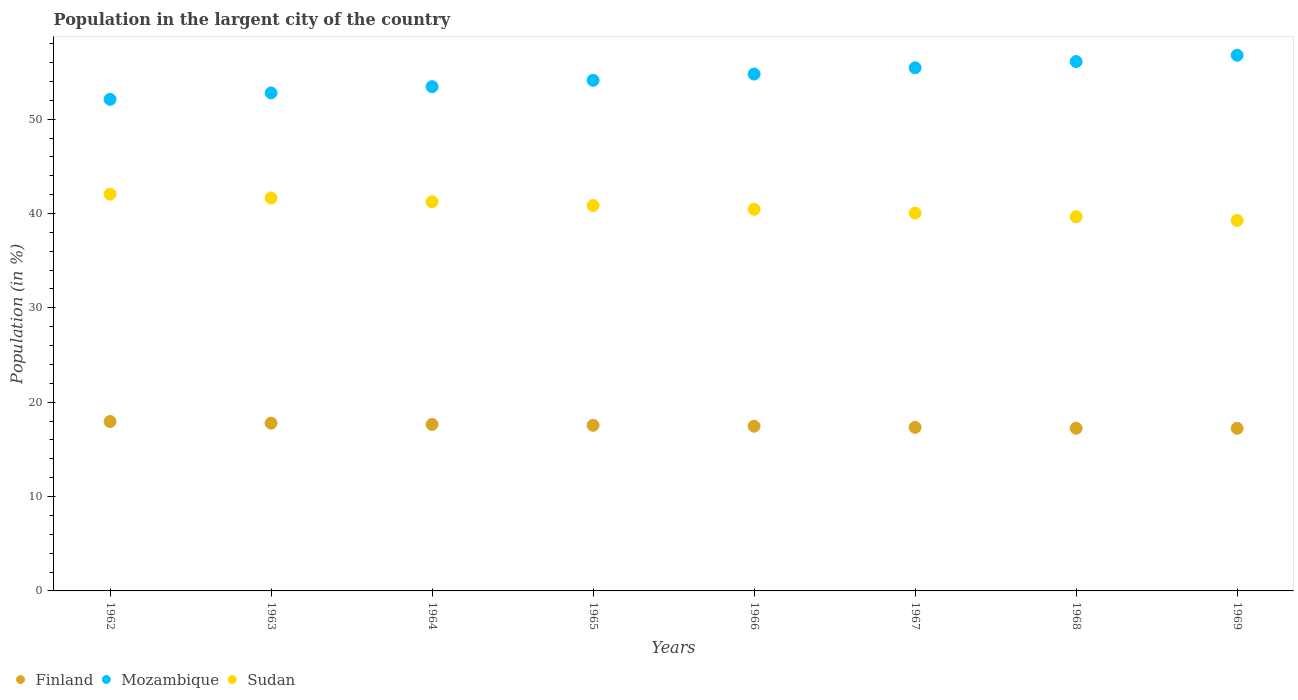Is the number of dotlines equal to the number of legend labels?
Make the answer very short. Yes. What is the percentage of population in the largent city in Mozambique in 1968?
Offer a very short reply. 56.11. Across all years, what is the maximum percentage of population in the largent city in Finland?
Offer a very short reply. 17.95. Across all years, what is the minimum percentage of population in the largent city in Sudan?
Ensure brevity in your answer.  39.27. In which year was the percentage of population in the largent city in Sudan maximum?
Ensure brevity in your answer.  1962. In which year was the percentage of population in the largent city in Finland minimum?
Provide a short and direct response. 1969. What is the total percentage of population in the largent city in Finland in the graph?
Offer a very short reply. 140.19. What is the difference between the percentage of population in the largent city in Sudan in 1962 and that in 1963?
Offer a very short reply. 0.4. What is the difference between the percentage of population in the largent city in Sudan in 1968 and the percentage of population in the largent city in Mozambique in 1965?
Your answer should be very brief. -14.46. What is the average percentage of population in the largent city in Mozambique per year?
Your answer should be compact. 54.44. In the year 1962, what is the difference between the percentage of population in the largent city in Finland and percentage of population in the largent city in Sudan?
Offer a terse response. -24.09. What is the ratio of the percentage of population in the largent city in Sudan in 1964 to that in 1966?
Your answer should be compact. 1.02. Is the difference between the percentage of population in the largent city in Finland in 1967 and 1969 greater than the difference between the percentage of population in the largent city in Sudan in 1967 and 1969?
Offer a very short reply. No. What is the difference between the highest and the second highest percentage of population in the largent city in Finland?
Provide a short and direct response. 0.17. What is the difference between the highest and the lowest percentage of population in the largent city in Sudan?
Your answer should be compact. 2.78. Is it the case that in every year, the sum of the percentage of population in the largent city in Finland and percentage of population in the largent city in Sudan  is greater than the percentage of population in the largent city in Mozambique?
Give a very brief answer. No. How many years are there in the graph?
Provide a short and direct response. 8. Where does the legend appear in the graph?
Your answer should be very brief. Bottom left. How many legend labels are there?
Give a very brief answer. 3. How are the legend labels stacked?
Keep it short and to the point. Horizontal. What is the title of the graph?
Your response must be concise. Population in the largent city of the country. Does "Paraguay" appear as one of the legend labels in the graph?
Your answer should be very brief. No. What is the label or title of the X-axis?
Your response must be concise. Years. What is the label or title of the Y-axis?
Your answer should be compact. Population (in %). What is the Population (in %) of Finland in 1962?
Your response must be concise. 17.95. What is the Population (in %) in Mozambique in 1962?
Offer a terse response. 52.1. What is the Population (in %) of Sudan in 1962?
Your response must be concise. 42.05. What is the Population (in %) of Finland in 1963?
Keep it short and to the point. 17.78. What is the Population (in %) of Mozambique in 1963?
Give a very brief answer. 52.78. What is the Population (in %) of Sudan in 1963?
Offer a terse response. 41.65. What is the Population (in %) of Finland in 1964?
Provide a short and direct response. 17.64. What is the Population (in %) of Mozambique in 1964?
Keep it short and to the point. 53.45. What is the Population (in %) of Sudan in 1964?
Offer a very short reply. 41.25. What is the Population (in %) of Finland in 1965?
Your answer should be very brief. 17.55. What is the Population (in %) in Mozambique in 1965?
Your answer should be compact. 54.12. What is the Population (in %) of Sudan in 1965?
Your response must be concise. 40.84. What is the Population (in %) in Finland in 1966?
Provide a succinct answer. 17.45. What is the Population (in %) in Mozambique in 1966?
Provide a short and direct response. 54.78. What is the Population (in %) of Sudan in 1966?
Your answer should be compact. 40.45. What is the Population (in %) of Finland in 1967?
Your response must be concise. 17.34. What is the Population (in %) in Mozambique in 1967?
Offer a very short reply. 55.44. What is the Population (in %) in Sudan in 1967?
Your answer should be very brief. 40.05. What is the Population (in %) in Finland in 1968?
Ensure brevity in your answer.  17.24. What is the Population (in %) in Mozambique in 1968?
Ensure brevity in your answer.  56.11. What is the Population (in %) of Sudan in 1968?
Ensure brevity in your answer.  39.66. What is the Population (in %) of Finland in 1969?
Provide a succinct answer. 17.23. What is the Population (in %) of Mozambique in 1969?
Provide a succinct answer. 56.78. What is the Population (in %) of Sudan in 1969?
Your response must be concise. 39.27. Across all years, what is the maximum Population (in %) in Finland?
Your answer should be very brief. 17.95. Across all years, what is the maximum Population (in %) of Mozambique?
Offer a very short reply. 56.78. Across all years, what is the maximum Population (in %) in Sudan?
Keep it short and to the point. 42.05. Across all years, what is the minimum Population (in %) in Finland?
Your answer should be very brief. 17.23. Across all years, what is the minimum Population (in %) of Mozambique?
Offer a very short reply. 52.1. Across all years, what is the minimum Population (in %) of Sudan?
Ensure brevity in your answer.  39.27. What is the total Population (in %) in Finland in the graph?
Your answer should be very brief. 140.19. What is the total Population (in %) in Mozambique in the graph?
Provide a short and direct response. 435.55. What is the total Population (in %) in Sudan in the graph?
Your response must be concise. 325.2. What is the difference between the Population (in %) of Finland in 1962 and that in 1963?
Make the answer very short. 0.17. What is the difference between the Population (in %) of Mozambique in 1962 and that in 1963?
Provide a short and direct response. -0.68. What is the difference between the Population (in %) of Sudan in 1962 and that in 1963?
Offer a terse response. 0.4. What is the difference between the Population (in %) in Finland in 1962 and that in 1964?
Give a very brief answer. 0.31. What is the difference between the Population (in %) in Mozambique in 1962 and that in 1964?
Your answer should be compact. -1.34. What is the difference between the Population (in %) in Sudan in 1962 and that in 1964?
Provide a succinct answer. 0.8. What is the difference between the Population (in %) in Finland in 1962 and that in 1965?
Offer a terse response. 0.4. What is the difference between the Population (in %) of Mozambique in 1962 and that in 1965?
Offer a very short reply. -2.02. What is the difference between the Population (in %) of Sudan in 1962 and that in 1965?
Make the answer very short. 1.2. What is the difference between the Population (in %) of Finland in 1962 and that in 1966?
Your response must be concise. 0.5. What is the difference between the Population (in %) in Mozambique in 1962 and that in 1966?
Provide a short and direct response. -2.68. What is the difference between the Population (in %) of Sudan in 1962 and that in 1966?
Your response must be concise. 1.6. What is the difference between the Population (in %) of Finland in 1962 and that in 1967?
Give a very brief answer. 0.62. What is the difference between the Population (in %) of Mozambique in 1962 and that in 1967?
Your response must be concise. -3.34. What is the difference between the Population (in %) of Sudan in 1962 and that in 1967?
Offer a terse response. 2. What is the difference between the Population (in %) of Finland in 1962 and that in 1968?
Make the answer very short. 0.72. What is the difference between the Population (in %) of Mozambique in 1962 and that in 1968?
Make the answer very short. -4. What is the difference between the Population (in %) in Sudan in 1962 and that in 1968?
Your answer should be very brief. 2.39. What is the difference between the Population (in %) in Finland in 1962 and that in 1969?
Ensure brevity in your answer.  0.72. What is the difference between the Population (in %) in Mozambique in 1962 and that in 1969?
Give a very brief answer. -4.67. What is the difference between the Population (in %) of Sudan in 1962 and that in 1969?
Offer a very short reply. 2.78. What is the difference between the Population (in %) of Finland in 1963 and that in 1964?
Offer a very short reply. 0.14. What is the difference between the Population (in %) of Mozambique in 1963 and that in 1964?
Ensure brevity in your answer.  -0.67. What is the difference between the Population (in %) in Sudan in 1963 and that in 1964?
Provide a succinct answer. 0.4. What is the difference between the Population (in %) in Finland in 1963 and that in 1965?
Your answer should be compact. 0.23. What is the difference between the Population (in %) in Mozambique in 1963 and that in 1965?
Your answer should be compact. -1.34. What is the difference between the Population (in %) of Sudan in 1963 and that in 1965?
Your answer should be compact. 0.8. What is the difference between the Population (in %) of Finland in 1963 and that in 1966?
Your answer should be very brief. 0.33. What is the difference between the Population (in %) in Mozambique in 1963 and that in 1966?
Offer a very short reply. -2. What is the difference between the Population (in %) of Sudan in 1963 and that in 1966?
Give a very brief answer. 1.2. What is the difference between the Population (in %) in Finland in 1963 and that in 1967?
Make the answer very short. 0.45. What is the difference between the Population (in %) of Mozambique in 1963 and that in 1967?
Your answer should be very brief. -2.66. What is the difference between the Population (in %) of Sudan in 1963 and that in 1967?
Provide a short and direct response. 1.6. What is the difference between the Population (in %) in Finland in 1963 and that in 1968?
Provide a succinct answer. 0.54. What is the difference between the Population (in %) of Mozambique in 1963 and that in 1968?
Your answer should be very brief. -3.32. What is the difference between the Population (in %) in Sudan in 1963 and that in 1968?
Provide a succinct answer. 1.99. What is the difference between the Population (in %) in Finland in 1963 and that in 1969?
Ensure brevity in your answer.  0.55. What is the difference between the Population (in %) in Mozambique in 1963 and that in 1969?
Provide a succinct answer. -4. What is the difference between the Population (in %) in Sudan in 1963 and that in 1969?
Provide a succinct answer. 2.38. What is the difference between the Population (in %) of Finland in 1964 and that in 1965?
Your response must be concise. 0.09. What is the difference between the Population (in %) in Mozambique in 1964 and that in 1965?
Give a very brief answer. -0.67. What is the difference between the Population (in %) of Sudan in 1964 and that in 1965?
Your answer should be compact. 0.4. What is the difference between the Population (in %) in Finland in 1964 and that in 1966?
Offer a very short reply. 0.19. What is the difference between the Population (in %) in Mozambique in 1964 and that in 1966?
Offer a very short reply. -1.33. What is the difference between the Population (in %) in Sudan in 1964 and that in 1966?
Your response must be concise. 0.8. What is the difference between the Population (in %) of Finland in 1964 and that in 1967?
Provide a short and direct response. 0.31. What is the difference between the Population (in %) in Mozambique in 1964 and that in 1967?
Provide a succinct answer. -2. What is the difference between the Population (in %) in Sudan in 1964 and that in 1967?
Your answer should be very brief. 1.2. What is the difference between the Population (in %) of Finland in 1964 and that in 1968?
Your response must be concise. 0.41. What is the difference between the Population (in %) in Mozambique in 1964 and that in 1968?
Make the answer very short. -2.66. What is the difference between the Population (in %) in Sudan in 1964 and that in 1968?
Keep it short and to the point. 1.59. What is the difference between the Population (in %) of Finland in 1964 and that in 1969?
Ensure brevity in your answer.  0.41. What is the difference between the Population (in %) in Mozambique in 1964 and that in 1969?
Give a very brief answer. -3.33. What is the difference between the Population (in %) in Sudan in 1964 and that in 1969?
Give a very brief answer. 1.98. What is the difference between the Population (in %) of Finland in 1965 and that in 1966?
Keep it short and to the point. 0.1. What is the difference between the Population (in %) of Mozambique in 1965 and that in 1966?
Give a very brief answer. -0.66. What is the difference between the Population (in %) in Sudan in 1965 and that in 1966?
Offer a very short reply. 0.4. What is the difference between the Population (in %) in Finland in 1965 and that in 1967?
Provide a succinct answer. 0.21. What is the difference between the Population (in %) in Mozambique in 1965 and that in 1967?
Make the answer very short. -1.32. What is the difference between the Population (in %) of Sudan in 1965 and that in 1967?
Provide a succinct answer. 0.8. What is the difference between the Population (in %) in Finland in 1965 and that in 1968?
Provide a short and direct response. 0.31. What is the difference between the Population (in %) in Mozambique in 1965 and that in 1968?
Your answer should be compact. -1.99. What is the difference between the Population (in %) in Sudan in 1965 and that in 1968?
Your response must be concise. 1.19. What is the difference between the Population (in %) of Finland in 1965 and that in 1969?
Offer a very short reply. 0.32. What is the difference between the Population (in %) in Mozambique in 1965 and that in 1969?
Provide a succinct answer. -2.66. What is the difference between the Population (in %) of Sudan in 1965 and that in 1969?
Provide a short and direct response. 1.58. What is the difference between the Population (in %) of Finland in 1966 and that in 1967?
Your answer should be compact. 0.12. What is the difference between the Population (in %) of Mozambique in 1966 and that in 1967?
Provide a short and direct response. -0.66. What is the difference between the Population (in %) of Sudan in 1966 and that in 1967?
Make the answer very short. 0.4. What is the difference between the Population (in %) in Finland in 1966 and that in 1968?
Give a very brief answer. 0.22. What is the difference between the Population (in %) of Mozambique in 1966 and that in 1968?
Provide a short and direct response. -1.32. What is the difference between the Population (in %) in Sudan in 1966 and that in 1968?
Provide a succinct answer. 0.79. What is the difference between the Population (in %) in Finland in 1966 and that in 1969?
Provide a succinct answer. 0.22. What is the difference between the Population (in %) in Mozambique in 1966 and that in 1969?
Give a very brief answer. -2. What is the difference between the Population (in %) of Sudan in 1966 and that in 1969?
Make the answer very short. 1.18. What is the difference between the Population (in %) in Finland in 1967 and that in 1968?
Give a very brief answer. 0.1. What is the difference between the Population (in %) of Mozambique in 1967 and that in 1968?
Make the answer very short. -0.66. What is the difference between the Population (in %) in Sudan in 1967 and that in 1968?
Your answer should be compact. 0.39. What is the difference between the Population (in %) in Finland in 1967 and that in 1969?
Make the answer very short. 0.1. What is the difference between the Population (in %) of Mozambique in 1967 and that in 1969?
Your answer should be compact. -1.33. What is the difference between the Population (in %) of Sudan in 1967 and that in 1969?
Keep it short and to the point. 0.78. What is the difference between the Population (in %) of Finland in 1968 and that in 1969?
Offer a very short reply. 0.01. What is the difference between the Population (in %) of Mozambique in 1968 and that in 1969?
Your answer should be compact. -0.67. What is the difference between the Population (in %) of Sudan in 1968 and that in 1969?
Give a very brief answer. 0.39. What is the difference between the Population (in %) in Finland in 1962 and the Population (in %) in Mozambique in 1963?
Give a very brief answer. -34.83. What is the difference between the Population (in %) in Finland in 1962 and the Population (in %) in Sudan in 1963?
Provide a short and direct response. -23.69. What is the difference between the Population (in %) of Mozambique in 1962 and the Population (in %) of Sudan in 1963?
Make the answer very short. 10.46. What is the difference between the Population (in %) in Finland in 1962 and the Population (in %) in Mozambique in 1964?
Your response must be concise. -35.49. What is the difference between the Population (in %) of Finland in 1962 and the Population (in %) of Sudan in 1964?
Provide a short and direct response. -23.29. What is the difference between the Population (in %) in Mozambique in 1962 and the Population (in %) in Sudan in 1964?
Give a very brief answer. 10.86. What is the difference between the Population (in %) in Finland in 1962 and the Population (in %) in Mozambique in 1965?
Offer a very short reply. -36.16. What is the difference between the Population (in %) of Finland in 1962 and the Population (in %) of Sudan in 1965?
Your response must be concise. -22.89. What is the difference between the Population (in %) in Mozambique in 1962 and the Population (in %) in Sudan in 1965?
Make the answer very short. 11.26. What is the difference between the Population (in %) in Finland in 1962 and the Population (in %) in Mozambique in 1966?
Offer a very short reply. -36.83. What is the difference between the Population (in %) in Finland in 1962 and the Population (in %) in Sudan in 1966?
Ensure brevity in your answer.  -22.49. What is the difference between the Population (in %) in Mozambique in 1962 and the Population (in %) in Sudan in 1966?
Provide a succinct answer. 11.66. What is the difference between the Population (in %) of Finland in 1962 and the Population (in %) of Mozambique in 1967?
Provide a short and direct response. -37.49. What is the difference between the Population (in %) in Finland in 1962 and the Population (in %) in Sudan in 1967?
Your answer should be compact. -22.09. What is the difference between the Population (in %) in Mozambique in 1962 and the Population (in %) in Sudan in 1967?
Offer a terse response. 12.05. What is the difference between the Population (in %) of Finland in 1962 and the Population (in %) of Mozambique in 1968?
Ensure brevity in your answer.  -38.15. What is the difference between the Population (in %) of Finland in 1962 and the Population (in %) of Sudan in 1968?
Your response must be concise. -21.7. What is the difference between the Population (in %) of Mozambique in 1962 and the Population (in %) of Sudan in 1968?
Provide a succinct answer. 12.45. What is the difference between the Population (in %) of Finland in 1962 and the Population (in %) of Mozambique in 1969?
Make the answer very short. -38.82. What is the difference between the Population (in %) in Finland in 1962 and the Population (in %) in Sudan in 1969?
Make the answer very short. -21.31. What is the difference between the Population (in %) in Mozambique in 1962 and the Population (in %) in Sudan in 1969?
Offer a terse response. 12.84. What is the difference between the Population (in %) in Finland in 1963 and the Population (in %) in Mozambique in 1964?
Offer a terse response. -35.66. What is the difference between the Population (in %) in Finland in 1963 and the Population (in %) in Sudan in 1964?
Your response must be concise. -23.46. What is the difference between the Population (in %) of Mozambique in 1963 and the Population (in %) of Sudan in 1964?
Ensure brevity in your answer.  11.53. What is the difference between the Population (in %) of Finland in 1963 and the Population (in %) of Mozambique in 1965?
Your response must be concise. -36.33. What is the difference between the Population (in %) of Finland in 1963 and the Population (in %) of Sudan in 1965?
Your response must be concise. -23.06. What is the difference between the Population (in %) in Mozambique in 1963 and the Population (in %) in Sudan in 1965?
Provide a short and direct response. 11.94. What is the difference between the Population (in %) in Finland in 1963 and the Population (in %) in Mozambique in 1966?
Your answer should be compact. -37. What is the difference between the Population (in %) in Finland in 1963 and the Population (in %) in Sudan in 1966?
Ensure brevity in your answer.  -22.66. What is the difference between the Population (in %) in Mozambique in 1963 and the Population (in %) in Sudan in 1966?
Make the answer very short. 12.33. What is the difference between the Population (in %) of Finland in 1963 and the Population (in %) of Mozambique in 1967?
Offer a very short reply. -37.66. What is the difference between the Population (in %) of Finland in 1963 and the Population (in %) of Sudan in 1967?
Your answer should be compact. -22.27. What is the difference between the Population (in %) of Mozambique in 1963 and the Population (in %) of Sudan in 1967?
Offer a terse response. 12.73. What is the difference between the Population (in %) in Finland in 1963 and the Population (in %) in Mozambique in 1968?
Keep it short and to the point. -38.32. What is the difference between the Population (in %) of Finland in 1963 and the Population (in %) of Sudan in 1968?
Give a very brief answer. -21.87. What is the difference between the Population (in %) of Mozambique in 1963 and the Population (in %) of Sudan in 1968?
Ensure brevity in your answer.  13.12. What is the difference between the Population (in %) in Finland in 1963 and the Population (in %) in Mozambique in 1969?
Provide a short and direct response. -38.99. What is the difference between the Population (in %) in Finland in 1963 and the Population (in %) in Sudan in 1969?
Provide a short and direct response. -21.48. What is the difference between the Population (in %) in Mozambique in 1963 and the Population (in %) in Sudan in 1969?
Your answer should be compact. 13.51. What is the difference between the Population (in %) of Finland in 1964 and the Population (in %) of Mozambique in 1965?
Provide a succinct answer. -36.47. What is the difference between the Population (in %) of Finland in 1964 and the Population (in %) of Sudan in 1965?
Offer a terse response. -23.2. What is the difference between the Population (in %) of Mozambique in 1964 and the Population (in %) of Sudan in 1965?
Your answer should be compact. 12.6. What is the difference between the Population (in %) in Finland in 1964 and the Population (in %) in Mozambique in 1966?
Provide a short and direct response. -37.14. What is the difference between the Population (in %) of Finland in 1964 and the Population (in %) of Sudan in 1966?
Provide a short and direct response. -22.8. What is the difference between the Population (in %) in Mozambique in 1964 and the Population (in %) in Sudan in 1966?
Provide a short and direct response. 13. What is the difference between the Population (in %) in Finland in 1964 and the Population (in %) in Mozambique in 1967?
Keep it short and to the point. -37.8. What is the difference between the Population (in %) of Finland in 1964 and the Population (in %) of Sudan in 1967?
Offer a terse response. -22.4. What is the difference between the Population (in %) of Mozambique in 1964 and the Population (in %) of Sudan in 1967?
Provide a succinct answer. 13.4. What is the difference between the Population (in %) in Finland in 1964 and the Population (in %) in Mozambique in 1968?
Your answer should be very brief. -38.46. What is the difference between the Population (in %) of Finland in 1964 and the Population (in %) of Sudan in 1968?
Provide a succinct answer. -22.01. What is the difference between the Population (in %) in Mozambique in 1964 and the Population (in %) in Sudan in 1968?
Keep it short and to the point. 13.79. What is the difference between the Population (in %) of Finland in 1964 and the Population (in %) of Mozambique in 1969?
Give a very brief answer. -39.13. What is the difference between the Population (in %) in Finland in 1964 and the Population (in %) in Sudan in 1969?
Your answer should be very brief. -21.62. What is the difference between the Population (in %) in Mozambique in 1964 and the Population (in %) in Sudan in 1969?
Give a very brief answer. 14.18. What is the difference between the Population (in %) in Finland in 1965 and the Population (in %) in Mozambique in 1966?
Give a very brief answer. -37.23. What is the difference between the Population (in %) of Finland in 1965 and the Population (in %) of Sudan in 1966?
Your response must be concise. -22.9. What is the difference between the Population (in %) of Mozambique in 1965 and the Population (in %) of Sudan in 1966?
Give a very brief answer. 13.67. What is the difference between the Population (in %) in Finland in 1965 and the Population (in %) in Mozambique in 1967?
Keep it short and to the point. -37.89. What is the difference between the Population (in %) in Finland in 1965 and the Population (in %) in Sudan in 1967?
Offer a very short reply. -22.5. What is the difference between the Population (in %) in Mozambique in 1965 and the Population (in %) in Sudan in 1967?
Your response must be concise. 14.07. What is the difference between the Population (in %) of Finland in 1965 and the Population (in %) of Mozambique in 1968?
Offer a very short reply. -38.55. What is the difference between the Population (in %) in Finland in 1965 and the Population (in %) in Sudan in 1968?
Keep it short and to the point. -22.11. What is the difference between the Population (in %) in Mozambique in 1965 and the Population (in %) in Sudan in 1968?
Your response must be concise. 14.46. What is the difference between the Population (in %) in Finland in 1965 and the Population (in %) in Mozambique in 1969?
Your answer should be compact. -39.23. What is the difference between the Population (in %) of Finland in 1965 and the Population (in %) of Sudan in 1969?
Provide a short and direct response. -21.72. What is the difference between the Population (in %) of Mozambique in 1965 and the Population (in %) of Sudan in 1969?
Your response must be concise. 14.85. What is the difference between the Population (in %) in Finland in 1966 and the Population (in %) in Mozambique in 1967?
Offer a terse response. -37.99. What is the difference between the Population (in %) of Finland in 1966 and the Population (in %) of Sudan in 1967?
Provide a short and direct response. -22.59. What is the difference between the Population (in %) of Mozambique in 1966 and the Population (in %) of Sudan in 1967?
Your answer should be very brief. 14.73. What is the difference between the Population (in %) in Finland in 1966 and the Population (in %) in Mozambique in 1968?
Give a very brief answer. -38.65. What is the difference between the Population (in %) of Finland in 1966 and the Population (in %) of Sudan in 1968?
Provide a short and direct response. -22.2. What is the difference between the Population (in %) in Mozambique in 1966 and the Population (in %) in Sudan in 1968?
Your answer should be very brief. 15.12. What is the difference between the Population (in %) in Finland in 1966 and the Population (in %) in Mozambique in 1969?
Make the answer very short. -39.32. What is the difference between the Population (in %) in Finland in 1966 and the Population (in %) in Sudan in 1969?
Your answer should be very brief. -21.81. What is the difference between the Population (in %) of Mozambique in 1966 and the Population (in %) of Sudan in 1969?
Your answer should be very brief. 15.51. What is the difference between the Population (in %) of Finland in 1967 and the Population (in %) of Mozambique in 1968?
Your response must be concise. -38.77. What is the difference between the Population (in %) in Finland in 1967 and the Population (in %) in Sudan in 1968?
Offer a terse response. -22.32. What is the difference between the Population (in %) of Mozambique in 1967 and the Population (in %) of Sudan in 1968?
Provide a succinct answer. 15.79. What is the difference between the Population (in %) of Finland in 1967 and the Population (in %) of Mozambique in 1969?
Offer a very short reply. -39.44. What is the difference between the Population (in %) of Finland in 1967 and the Population (in %) of Sudan in 1969?
Your answer should be compact. -21.93. What is the difference between the Population (in %) in Mozambique in 1967 and the Population (in %) in Sudan in 1969?
Keep it short and to the point. 16.18. What is the difference between the Population (in %) in Finland in 1968 and the Population (in %) in Mozambique in 1969?
Ensure brevity in your answer.  -39.54. What is the difference between the Population (in %) of Finland in 1968 and the Population (in %) of Sudan in 1969?
Offer a very short reply. -22.03. What is the difference between the Population (in %) in Mozambique in 1968 and the Population (in %) in Sudan in 1969?
Your response must be concise. 16.84. What is the average Population (in %) of Finland per year?
Your answer should be compact. 17.52. What is the average Population (in %) of Mozambique per year?
Provide a short and direct response. 54.44. What is the average Population (in %) in Sudan per year?
Provide a short and direct response. 40.65. In the year 1962, what is the difference between the Population (in %) of Finland and Population (in %) of Mozambique?
Your response must be concise. -34.15. In the year 1962, what is the difference between the Population (in %) of Finland and Population (in %) of Sudan?
Your answer should be compact. -24.09. In the year 1962, what is the difference between the Population (in %) in Mozambique and Population (in %) in Sudan?
Provide a succinct answer. 10.06. In the year 1963, what is the difference between the Population (in %) in Finland and Population (in %) in Mozambique?
Your answer should be compact. -35. In the year 1963, what is the difference between the Population (in %) of Finland and Population (in %) of Sudan?
Provide a succinct answer. -23.86. In the year 1963, what is the difference between the Population (in %) in Mozambique and Population (in %) in Sudan?
Your response must be concise. 11.13. In the year 1964, what is the difference between the Population (in %) in Finland and Population (in %) in Mozambique?
Give a very brief answer. -35.8. In the year 1964, what is the difference between the Population (in %) in Finland and Population (in %) in Sudan?
Provide a short and direct response. -23.6. In the year 1964, what is the difference between the Population (in %) of Mozambique and Population (in %) of Sudan?
Offer a terse response. 12.2. In the year 1965, what is the difference between the Population (in %) in Finland and Population (in %) in Mozambique?
Offer a very short reply. -36.57. In the year 1965, what is the difference between the Population (in %) of Finland and Population (in %) of Sudan?
Provide a succinct answer. -23.29. In the year 1965, what is the difference between the Population (in %) of Mozambique and Population (in %) of Sudan?
Provide a short and direct response. 13.27. In the year 1966, what is the difference between the Population (in %) of Finland and Population (in %) of Mozambique?
Make the answer very short. -37.33. In the year 1966, what is the difference between the Population (in %) of Finland and Population (in %) of Sudan?
Your answer should be compact. -22.99. In the year 1966, what is the difference between the Population (in %) of Mozambique and Population (in %) of Sudan?
Give a very brief answer. 14.33. In the year 1967, what is the difference between the Population (in %) in Finland and Population (in %) in Mozambique?
Give a very brief answer. -38.11. In the year 1967, what is the difference between the Population (in %) in Finland and Population (in %) in Sudan?
Offer a terse response. -22.71. In the year 1967, what is the difference between the Population (in %) of Mozambique and Population (in %) of Sudan?
Your answer should be very brief. 15.39. In the year 1968, what is the difference between the Population (in %) of Finland and Population (in %) of Mozambique?
Offer a very short reply. -38.87. In the year 1968, what is the difference between the Population (in %) in Finland and Population (in %) in Sudan?
Keep it short and to the point. -22.42. In the year 1968, what is the difference between the Population (in %) in Mozambique and Population (in %) in Sudan?
Keep it short and to the point. 16.45. In the year 1969, what is the difference between the Population (in %) of Finland and Population (in %) of Mozambique?
Provide a succinct answer. -39.54. In the year 1969, what is the difference between the Population (in %) in Finland and Population (in %) in Sudan?
Offer a terse response. -22.03. In the year 1969, what is the difference between the Population (in %) of Mozambique and Population (in %) of Sudan?
Offer a very short reply. 17.51. What is the ratio of the Population (in %) in Finland in 1962 to that in 1963?
Offer a very short reply. 1.01. What is the ratio of the Population (in %) of Mozambique in 1962 to that in 1963?
Give a very brief answer. 0.99. What is the ratio of the Population (in %) of Sudan in 1962 to that in 1963?
Provide a succinct answer. 1.01. What is the ratio of the Population (in %) in Finland in 1962 to that in 1964?
Provide a short and direct response. 1.02. What is the ratio of the Population (in %) in Mozambique in 1962 to that in 1964?
Offer a very short reply. 0.97. What is the ratio of the Population (in %) of Sudan in 1962 to that in 1964?
Your answer should be compact. 1.02. What is the ratio of the Population (in %) of Finland in 1962 to that in 1965?
Keep it short and to the point. 1.02. What is the ratio of the Population (in %) in Mozambique in 1962 to that in 1965?
Keep it short and to the point. 0.96. What is the ratio of the Population (in %) in Sudan in 1962 to that in 1965?
Ensure brevity in your answer.  1.03. What is the ratio of the Population (in %) of Finland in 1962 to that in 1966?
Your response must be concise. 1.03. What is the ratio of the Population (in %) of Mozambique in 1962 to that in 1966?
Your answer should be very brief. 0.95. What is the ratio of the Population (in %) of Sudan in 1962 to that in 1966?
Make the answer very short. 1.04. What is the ratio of the Population (in %) in Finland in 1962 to that in 1967?
Offer a terse response. 1.04. What is the ratio of the Population (in %) of Mozambique in 1962 to that in 1967?
Your answer should be very brief. 0.94. What is the ratio of the Population (in %) in Sudan in 1962 to that in 1967?
Provide a succinct answer. 1.05. What is the ratio of the Population (in %) in Finland in 1962 to that in 1968?
Offer a very short reply. 1.04. What is the ratio of the Population (in %) in Mozambique in 1962 to that in 1968?
Your answer should be compact. 0.93. What is the ratio of the Population (in %) of Sudan in 1962 to that in 1968?
Your answer should be very brief. 1.06. What is the ratio of the Population (in %) of Finland in 1962 to that in 1969?
Give a very brief answer. 1.04. What is the ratio of the Population (in %) in Mozambique in 1962 to that in 1969?
Ensure brevity in your answer.  0.92. What is the ratio of the Population (in %) of Sudan in 1962 to that in 1969?
Make the answer very short. 1.07. What is the ratio of the Population (in %) of Finland in 1963 to that in 1964?
Keep it short and to the point. 1.01. What is the ratio of the Population (in %) of Mozambique in 1963 to that in 1964?
Your response must be concise. 0.99. What is the ratio of the Population (in %) in Sudan in 1963 to that in 1964?
Give a very brief answer. 1.01. What is the ratio of the Population (in %) of Finland in 1963 to that in 1965?
Offer a very short reply. 1.01. What is the ratio of the Population (in %) of Mozambique in 1963 to that in 1965?
Keep it short and to the point. 0.98. What is the ratio of the Population (in %) in Sudan in 1963 to that in 1965?
Give a very brief answer. 1.02. What is the ratio of the Population (in %) in Finland in 1963 to that in 1966?
Provide a short and direct response. 1.02. What is the ratio of the Population (in %) in Mozambique in 1963 to that in 1966?
Provide a succinct answer. 0.96. What is the ratio of the Population (in %) in Sudan in 1963 to that in 1966?
Offer a very short reply. 1.03. What is the ratio of the Population (in %) of Finland in 1963 to that in 1967?
Your answer should be very brief. 1.03. What is the ratio of the Population (in %) in Sudan in 1963 to that in 1967?
Provide a succinct answer. 1.04. What is the ratio of the Population (in %) of Finland in 1963 to that in 1968?
Your response must be concise. 1.03. What is the ratio of the Population (in %) in Mozambique in 1963 to that in 1968?
Make the answer very short. 0.94. What is the ratio of the Population (in %) of Sudan in 1963 to that in 1968?
Give a very brief answer. 1.05. What is the ratio of the Population (in %) in Finland in 1963 to that in 1969?
Keep it short and to the point. 1.03. What is the ratio of the Population (in %) of Mozambique in 1963 to that in 1969?
Your response must be concise. 0.93. What is the ratio of the Population (in %) of Sudan in 1963 to that in 1969?
Your answer should be compact. 1.06. What is the ratio of the Population (in %) in Mozambique in 1964 to that in 1965?
Ensure brevity in your answer.  0.99. What is the ratio of the Population (in %) in Sudan in 1964 to that in 1965?
Make the answer very short. 1.01. What is the ratio of the Population (in %) of Finland in 1964 to that in 1966?
Your answer should be compact. 1.01. What is the ratio of the Population (in %) in Mozambique in 1964 to that in 1966?
Give a very brief answer. 0.98. What is the ratio of the Population (in %) in Sudan in 1964 to that in 1966?
Provide a succinct answer. 1.02. What is the ratio of the Population (in %) in Finland in 1964 to that in 1967?
Your answer should be compact. 1.02. What is the ratio of the Population (in %) of Sudan in 1964 to that in 1967?
Provide a short and direct response. 1.03. What is the ratio of the Population (in %) in Finland in 1964 to that in 1968?
Provide a short and direct response. 1.02. What is the ratio of the Population (in %) in Mozambique in 1964 to that in 1968?
Ensure brevity in your answer.  0.95. What is the ratio of the Population (in %) of Sudan in 1964 to that in 1968?
Provide a succinct answer. 1.04. What is the ratio of the Population (in %) in Finland in 1964 to that in 1969?
Provide a succinct answer. 1.02. What is the ratio of the Population (in %) in Mozambique in 1964 to that in 1969?
Offer a terse response. 0.94. What is the ratio of the Population (in %) of Sudan in 1964 to that in 1969?
Provide a short and direct response. 1.05. What is the ratio of the Population (in %) in Mozambique in 1965 to that in 1966?
Your response must be concise. 0.99. What is the ratio of the Population (in %) in Sudan in 1965 to that in 1966?
Your answer should be compact. 1.01. What is the ratio of the Population (in %) in Finland in 1965 to that in 1967?
Your answer should be very brief. 1.01. What is the ratio of the Population (in %) of Mozambique in 1965 to that in 1967?
Offer a very short reply. 0.98. What is the ratio of the Population (in %) of Sudan in 1965 to that in 1967?
Your response must be concise. 1.02. What is the ratio of the Population (in %) in Finland in 1965 to that in 1968?
Provide a succinct answer. 1.02. What is the ratio of the Population (in %) of Mozambique in 1965 to that in 1968?
Keep it short and to the point. 0.96. What is the ratio of the Population (in %) of Sudan in 1965 to that in 1968?
Ensure brevity in your answer.  1.03. What is the ratio of the Population (in %) of Finland in 1965 to that in 1969?
Give a very brief answer. 1.02. What is the ratio of the Population (in %) in Mozambique in 1965 to that in 1969?
Provide a succinct answer. 0.95. What is the ratio of the Population (in %) in Sudan in 1965 to that in 1969?
Your response must be concise. 1.04. What is the ratio of the Population (in %) in Mozambique in 1966 to that in 1967?
Offer a very short reply. 0.99. What is the ratio of the Population (in %) of Sudan in 1966 to that in 1967?
Your response must be concise. 1.01. What is the ratio of the Population (in %) of Finland in 1966 to that in 1968?
Ensure brevity in your answer.  1.01. What is the ratio of the Population (in %) of Mozambique in 1966 to that in 1968?
Offer a terse response. 0.98. What is the ratio of the Population (in %) of Sudan in 1966 to that in 1968?
Your response must be concise. 1.02. What is the ratio of the Population (in %) in Finland in 1966 to that in 1969?
Provide a short and direct response. 1.01. What is the ratio of the Population (in %) in Mozambique in 1966 to that in 1969?
Offer a terse response. 0.96. What is the ratio of the Population (in %) in Sudan in 1966 to that in 1969?
Offer a terse response. 1.03. What is the ratio of the Population (in %) in Finland in 1967 to that in 1968?
Make the answer very short. 1.01. What is the ratio of the Population (in %) in Sudan in 1967 to that in 1968?
Offer a terse response. 1.01. What is the ratio of the Population (in %) of Mozambique in 1967 to that in 1969?
Your answer should be compact. 0.98. What is the ratio of the Population (in %) of Sudan in 1967 to that in 1969?
Offer a very short reply. 1.02. What is the ratio of the Population (in %) in Finland in 1968 to that in 1969?
Your answer should be compact. 1. What is the ratio of the Population (in %) of Sudan in 1968 to that in 1969?
Your response must be concise. 1.01. What is the difference between the highest and the second highest Population (in %) in Finland?
Offer a terse response. 0.17. What is the difference between the highest and the second highest Population (in %) of Mozambique?
Keep it short and to the point. 0.67. What is the difference between the highest and the second highest Population (in %) of Sudan?
Give a very brief answer. 0.4. What is the difference between the highest and the lowest Population (in %) in Finland?
Your answer should be compact. 0.72. What is the difference between the highest and the lowest Population (in %) of Mozambique?
Keep it short and to the point. 4.67. What is the difference between the highest and the lowest Population (in %) in Sudan?
Your response must be concise. 2.78. 